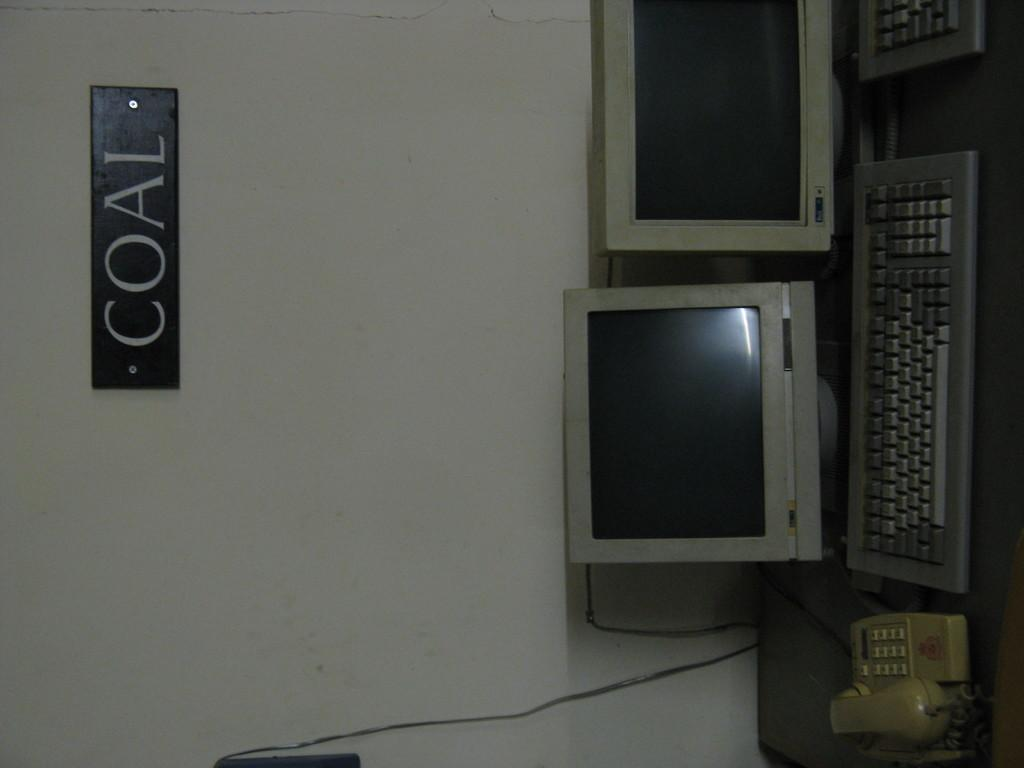<image>
Offer a succinct explanation of the picture presented. A sign that reads coal hovers above a desk with some monitors, keyboards and a phone. 